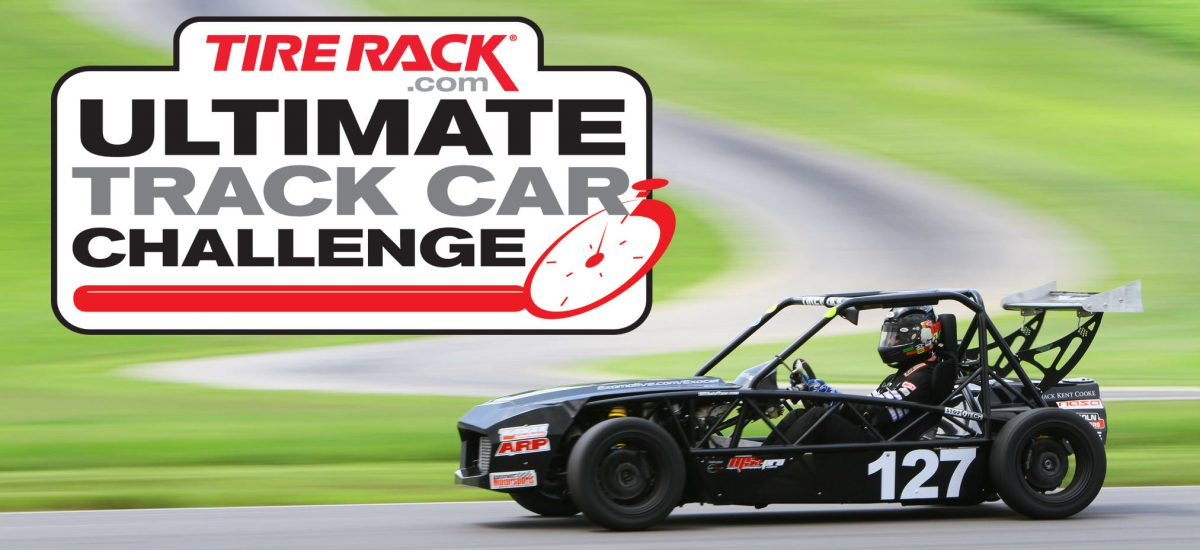Given the design and construction of the car, what specific race categories or events could this vehicle be eligible to compete in, and what characteristics of the car support this assessment? Based on the visible design and construction of the vehicle, it appears to be built for events such as time trials or autocross competitions where the focus is on the agility and speed of the car in a solo racing format, rather than wheel-to-wheel racing. The vehicle's lightweight frame, large rear wing, and open-wheel design suggest that it is optimized for aerodynamic efficiency and agility, characteristics crucial for such competitive racing events. 